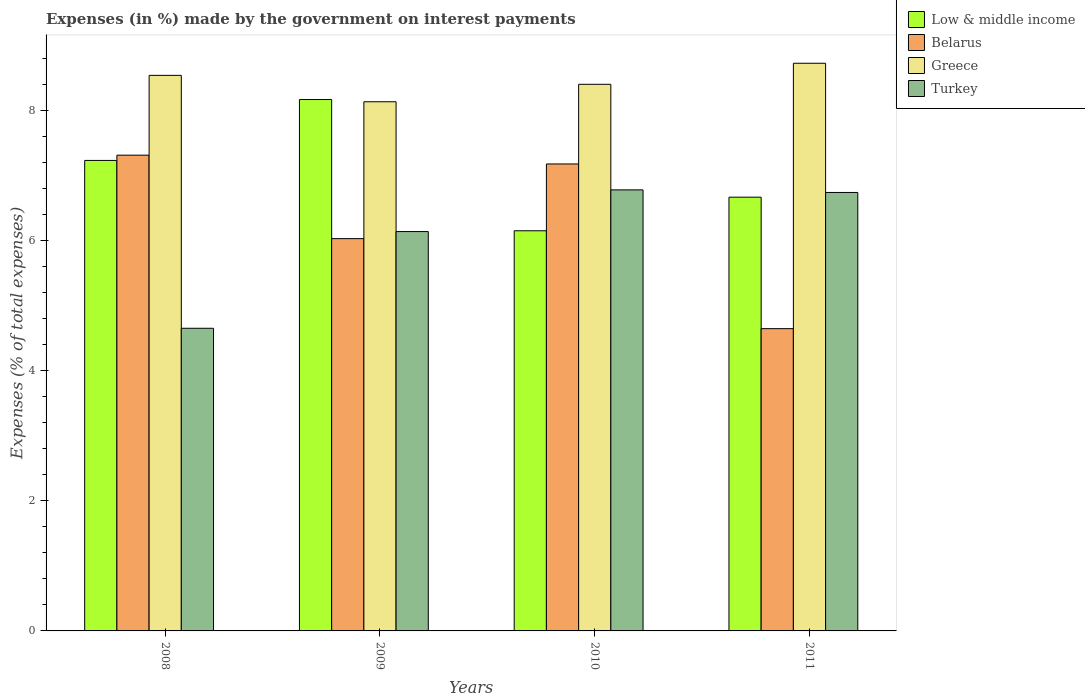How many different coloured bars are there?
Provide a short and direct response. 4. Are the number of bars on each tick of the X-axis equal?
Provide a short and direct response. Yes. What is the label of the 4th group of bars from the left?
Offer a terse response. 2011. What is the percentage of expenses made by the government on interest payments in Turkey in 2008?
Keep it short and to the point. 4.65. Across all years, what is the maximum percentage of expenses made by the government on interest payments in Greece?
Your response must be concise. 8.73. Across all years, what is the minimum percentage of expenses made by the government on interest payments in Low & middle income?
Give a very brief answer. 6.15. In which year was the percentage of expenses made by the government on interest payments in Greece maximum?
Make the answer very short. 2011. In which year was the percentage of expenses made by the government on interest payments in Greece minimum?
Make the answer very short. 2009. What is the total percentage of expenses made by the government on interest payments in Low & middle income in the graph?
Your response must be concise. 28.23. What is the difference between the percentage of expenses made by the government on interest payments in Belarus in 2008 and that in 2010?
Provide a short and direct response. 0.14. What is the difference between the percentage of expenses made by the government on interest payments in Low & middle income in 2010 and the percentage of expenses made by the government on interest payments in Turkey in 2009?
Keep it short and to the point. 0.01. What is the average percentage of expenses made by the government on interest payments in Greece per year?
Ensure brevity in your answer.  8.45. In the year 2009, what is the difference between the percentage of expenses made by the government on interest payments in Greece and percentage of expenses made by the government on interest payments in Low & middle income?
Your response must be concise. -0.03. In how many years, is the percentage of expenses made by the government on interest payments in Low & middle income greater than 4 %?
Keep it short and to the point. 4. What is the ratio of the percentage of expenses made by the government on interest payments in Turkey in 2008 to that in 2011?
Your response must be concise. 0.69. What is the difference between the highest and the second highest percentage of expenses made by the government on interest payments in Turkey?
Ensure brevity in your answer.  0.04. What is the difference between the highest and the lowest percentage of expenses made by the government on interest payments in Low & middle income?
Provide a short and direct response. 2.02. Is it the case that in every year, the sum of the percentage of expenses made by the government on interest payments in Greece and percentage of expenses made by the government on interest payments in Turkey is greater than the sum of percentage of expenses made by the government on interest payments in Low & middle income and percentage of expenses made by the government on interest payments in Belarus?
Give a very brief answer. No. Is it the case that in every year, the sum of the percentage of expenses made by the government on interest payments in Low & middle income and percentage of expenses made by the government on interest payments in Belarus is greater than the percentage of expenses made by the government on interest payments in Greece?
Your answer should be compact. Yes. How many bars are there?
Keep it short and to the point. 16. How many years are there in the graph?
Offer a terse response. 4. Are the values on the major ticks of Y-axis written in scientific E-notation?
Your answer should be compact. No. Does the graph contain grids?
Provide a succinct answer. No. What is the title of the graph?
Provide a short and direct response. Expenses (in %) made by the government on interest payments. What is the label or title of the X-axis?
Offer a very short reply. Years. What is the label or title of the Y-axis?
Make the answer very short. Expenses (% of total expenses). What is the Expenses (% of total expenses) of Low & middle income in 2008?
Your answer should be very brief. 7.24. What is the Expenses (% of total expenses) of Belarus in 2008?
Give a very brief answer. 7.32. What is the Expenses (% of total expenses) of Greece in 2008?
Ensure brevity in your answer.  8.54. What is the Expenses (% of total expenses) of Turkey in 2008?
Your response must be concise. 4.65. What is the Expenses (% of total expenses) in Low & middle income in 2009?
Your response must be concise. 8.17. What is the Expenses (% of total expenses) of Belarus in 2009?
Your answer should be compact. 6.03. What is the Expenses (% of total expenses) of Greece in 2009?
Provide a succinct answer. 8.14. What is the Expenses (% of total expenses) of Turkey in 2009?
Provide a succinct answer. 6.14. What is the Expenses (% of total expenses) in Low & middle income in 2010?
Provide a short and direct response. 6.15. What is the Expenses (% of total expenses) in Belarus in 2010?
Make the answer very short. 7.18. What is the Expenses (% of total expenses) of Greece in 2010?
Provide a succinct answer. 8.41. What is the Expenses (% of total expenses) in Turkey in 2010?
Make the answer very short. 6.78. What is the Expenses (% of total expenses) in Low & middle income in 2011?
Keep it short and to the point. 6.67. What is the Expenses (% of total expenses) in Belarus in 2011?
Keep it short and to the point. 4.65. What is the Expenses (% of total expenses) in Greece in 2011?
Make the answer very short. 8.73. What is the Expenses (% of total expenses) of Turkey in 2011?
Provide a succinct answer. 6.74. Across all years, what is the maximum Expenses (% of total expenses) of Low & middle income?
Give a very brief answer. 8.17. Across all years, what is the maximum Expenses (% of total expenses) of Belarus?
Ensure brevity in your answer.  7.32. Across all years, what is the maximum Expenses (% of total expenses) of Greece?
Ensure brevity in your answer.  8.73. Across all years, what is the maximum Expenses (% of total expenses) in Turkey?
Your response must be concise. 6.78. Across all years, what is the minimum Expenses (% of total expenses) of Low & middle income?
Give a very brief answer. 6.15. Across all years, what is the minimum Expenses (% of total expenses) of Belarus?
Keep it short and to the point. 4.65. Across all years, what is the minimum Expenses (% of total expenses) in Greece?
Provide a short and direct response. 8.14. Across all years, what is the minimum Expenses (% of total expenses) in Turkey?
Make the answer very short. 4.65. What is the total Expenses (% of total expenses) in Low & middle income in the graph?
Offer a terse response. 28.23. What is the total Expenses (% of total expenses) in Belarus in the graph?
Provide a short and direct response. 25.18. What is the total Expenses (% of total expenses) of Greece in the graph?
Offer a terse response. 33.82. What is the total Expenses (% of total expenses) in Turkey in the graph?
Provide a short and direct response. 24.32. What is the difference between the Expenses (% of total expenses) in Low & middle income in 2008 and that in 2009?
Provide a short and direct response. -0.94. What is the difference between the Expenses (% of total expenses) in Belarus in 2008 and that in 2009?
Ensure brevity in your answer.  1.28. What is the difference between the Expenses (% of total expenses) of Greece in 2008 and that in 2009?
Offer a terse response. 0.41. What is the difference between the Expenses (% of total expenses) of Turkey in 2008 and that in 2009?
Your answer should be very brief. -1.49. What is the difference between the Expenses (% of total expenses) of Low & middle income in 2008 and that in 2010?
Your answer should be compact. 1.08. What is the difference between the Expenses (% of total expenses) of Belarus in 2008 and that in 2010?
Offer a very short reply. 0.14. What is the difference between the Expenses (% of total expenses) of Greece in 2008 and that in 2010?
Provide a succinct answer. 0.14. What is the difference between the Expenses (% of total expenses) in Turkey in 2008 and that in 2010?
Offer a terse response. -2.13. What is the difference between the Expenses (% of total expenses) of Low & middle income in 2008 and that in 2011?
Offer a terse response. 0.56. What is the difference between the Expenses (% of total expenses) of Belarus in 2008 and that in 2011?
Your answer should be very brief. 2.67. What is the difference between the Expenses (% of total expenses) of Greece in 2008 and that in 2011?
Keep it short and to the point. -0.19. What is the difference between the Expenses (% of total expenses) in Turkey in 2008 and that in 2011?
Your response must be concise. -2.09. What is the difference between the Expenses (% of total expenses) in Low & middle income in 2009 and that in 2010?
Provide a short and direct response. 2.02. What is the difference between the Expenses (% of total expenses) in Belarus in 2009 and that in 2010?
Make the answer very short. -1.15. What is the difference between the Expenses (% of total expenses) in Greece in 2009 and that in 2010?
Offer a very short reply. -0.27. What is the difference between the Expenses (% of total expenses) in Turkey in 2009 and that in 2010?
Your answer should be compact. -0.64. What is the difference between the Expenses (% of total expenses) in Low & middle income in 2009 and that in 2011?
Make the answer very short. 1.5. What is the difference between the Expenses (% of total expenses) of Belarus in 2009 and that in 2011?
Make the answer very short. 1.38. What is the difference between the Expenses (% of total expenses) in Greece in 2009 and that in 2011?
Provide a succinct answer. -0.59. What is the difference between the Expenses (% of total expenses) of Turkey in 2009 and that in 2011?
Offer a terse response. -0.6. What is the difference between the Expenses (% of total expenses) of Low & middle income in 2010 and that in 2011?
Make the answer very short. -0.52. What is the difference between the Expenses (% of total expenses) of Belarus in 2010 and that in 2011?
Offer a terse response. 2.53. What is the difference between the Expenses (% of total expenses) in Greece in 2010 and that in 2011?
Make the answer very short. -0.32. What is the difference between the Expenses (% of total expenses) in Turkey in 2010 and that in 2011?
Offer a terse response. 0.04. What is the difference between the Expenses (% of total expenses) in Low & middle income in 2008 and the Expenses (% of total expenses) in Belarus in 2009?
Your answer should be very brief. 1.2. What is the difference between the Expenses (% of total expenses) in Low & middle income in 2008 and the Expenses (% of total expenses) in Greece in 2009?
Your response must be concise. -0.9. What is the difference between the Expenses (% of total expenses) in Low & middle income in 2008 and the Expenses (% of total expenses) in Turkey in 2009?
Offer a terse response. 1.09. What is the difference between the Expenses (% of total expenses) of Belarus in 2008 and the Expenses (% of total expenses) of Greece in 2009?
Your answer should be very brief. -0.82. What is the difference between the Expenses (% of total expenses) in Belarus in 2008 and the Expenses (% of total expenses) in Turkey in 2009?
Offer a very short reply. 1.18. What is the difference between the Expenses (% of total expenses) in Greece in 2008 and the Expenses (% of total expenses) in Turkey in 2009?
Give a very brief answer. 2.4. What is the difference between the Expenses (% of total expenses) in Low & middle income in 2008 and the Expenses (% of total expenses) in Belarus in 2010?
Provide a succinct answer. 0.05. What is the difference between the Expenses (% of total expenses) of Low & middle income in 2008 and the Expenses (% of total expenses) of Greece in 2010?
Keep it short and to the point. -1.17. What is the difference between the Expenses (% of total expenses) of Low & middle income in 2008 and the Expenses (% of total expenses) of Turkey in 2010?
Provide a succinct answer. 0.45. What is the difference between the Expenses (% of total expenses) of Belarus in 2008 and the Expenses (% of total expenses) of Greece in 2010?
Make the answer very short. -1.09. What is the difference between the Expenses (% of total expenses) of Belarus in 2008 and the Expenses (% of total expenses) of Turkey in 2010?
Your answer should be compact. 0.53. What is the difference between the Expenses (% of total expenses) in Greece in 2008 and the Expenses (% of total expenses) in Turkey in 2010?
Your answer should be compact. 1.76. What is the difference between the Expenses (% of total expenses) in Low & middle income in 2008 and the Expenses (% of total expenses) in Belarus in 2011?
Provide a short and direct response. 2.59. What is the difference between the Expenses (% of total expenses) of Low & middle income in 2008 and the Expenses (% of total expenses) of Greece in 2011?
Give a very brief answer. -1.49. What is the difference between the Expenses (% of total expenses) in Low & middle income in 2008 and the Expenses (% of total expenses) in Turkey in 2011?
Your answer should be very brief. 0.49. What is the difference between the Expenses (% of total expenses) in Belarus in 2008 and the Expenses (% of total expenses) in Greece in 2011?
Offer a terse response. -1.41. What is the difference between the Expenses (% of total expenses) in Belarus in 2008 and the Expenses (% of total expenses) in Turkey in 2011?
Ensure brevity in your answer.  0.57. What is the difference between the Expenses (% of total expenses) in Greece in 2008 and the Expenses (% of total expenses) in Turkey in 2011?
Provide a succinct answer. 1.8. What is the difference between the Expenses (% of total expenses) in Low & middle income in 2009 and the Expenses (% of total expenses) in Belarus in 2010?
Your answer should be very brief. 0.99. What is the difference between the Expenses (% of total expenses) of Low & middle income in 2009 and the Expenses (% of total expenses) of Greece in 2010?
Your answer should be very brief. -0.23. What is the difference between the Expenses (% of total expenses) in Low & middle income in 2009 and the Expenses (% of total expenses) in Turkey in 2010?
Give a very brief answer. 1.39. What is the difference between the Expenses (% of total expenses) in Belarus in 2009 and the Expenses (% of total expenses) in Greece in 2010?
Provide a short and direct response. -2.37. What is the difference between the Expenses (% of total expenses) of Belarus in 2009 and the Expenses (% of total expenses) of Turkey in 2010?
Ensure brevity in your answer.  -0.75. What is the difference between the Expenses (% of total expenses) in Greece in 2009 and the Expenses (% of total expenses) in Turkey in 2010?
Keep it short and to the point. 1.36. What is the difference between the Expenses (% of total expenses) of Low & middle income in 2009 and the Expenses (% of total expenses) of Belarus in 2011?
Keep it short and to the point. 3.52. What is the difference between the Expenses (% of total expenses) of Low & middle income in 2009 and the Expenses (% of total expenses) of Greece in 2011?
Provide a succinct answer. -0.56. What is the difference between the Expenses (% of total expenses) in Low & middle income in 2009 and the Expenses (% of total expenses) in Turkey in 2011?
Provide a short and direct response. 1.43. What is the difference between the Expenses (% of total expenses) in Belarus in 2009 and the Expenses (% of total expenses) in Greece in 2011?
Your answer should be compact. -2.7. What is the difference between the Expenses (% of total expenses) in Belarus in 2009 and the Expenses (% of total expenses) in Turkey in 2011?
Keep it short and to the point. -0.71. What is the difference between the Expenses (% of total expenses) of Greece in 2009 and the Expenses (% of total expenses) of Turkey in 2011?
Provide a short and direct response. 1.4. What is the difference between the Expenses (% of total expenses) of Low & middle income in 2010 and the Expenses (% of total expenses) of Belarus in 2011?
Provide a short and direct response. 1.51. What is the difference between the Expenses (% of total expenses) in Low & middle income in 2010 and the Expenses (% of total expenses) in Greece in 2011?
Your answer should be very brief. -2.58. What is the difference between the Expenses (% of total expenses) of Low & middle income in 2010 and the Expenses (% of total expenses) of Turkey in 2011?
Give a very brief answer. -0.59. What is the difference between the Expenses (% of total expenses) of Belarus in 2010 and the Expenses (% of total expenses) of Greece in 2011?
Provide a succinct answer. -1.55. What is the difference between the Expenses (% of total expenses) of Belarus in 2010 and the Expenses (% of total expenses) of Turkey in 2011?
Make the answer very short. 0.44. What is the difference between the Expenses (% of total expenses) of Greece in 2010 and the Expenses (% of total expenses) of Turkey in 2011?
Keep it short and to the point. 1.66. What is the average Expenses (% of total expenses) in Low & middle income per year?
Your response must be concise. 7.06. What is the average Expenses (% of total expenses) of Belarus per year?
Offer a very short reply. 6.29. What is the average Expenses (% of total expenses) in Greece per year?
Offer a very short reply. 8.45. What is the average Expenses (% of total expenses) in Turkey per year?
Your response must be concise. 6.08. In the year 2008, what is the difference between the Expenses (% of total expenses) in Low & middle income and Expenses (% of total expenses) in Belarus?
Ensure brevity in your answer.  -0.08. In the year 2008, what is the difference between the Expenses (% of total expenses) in Low & middle income and Expenses (% of total expenses) in Greece?
Your answer should be compact. -1.31. In the year 2008, what is the difference between the Expenses (% of total expenses) of Low & middle income and Expenses (% of total expenses) of Turkey?
Offer a terse response. 2.58. In the year 2008, what is the difference between the Expenses (% of total expenses) of Belarus and Expenses (% of total expenses) of Greece?
Offer a very short reply. -1.23. In the year 2008, what is the difference between the Expenses (% of total expenses) of Belarus and Expenses (% of total expenses) of Turkey?
Give a very brief answer. 2.66. In the year 2008, what is the difference between the Expenses (% of total expenses) in Greece and Expenses (% of total expenses) in Turkey?
Your response must be concise. 3.89. In the year 2009, what is the difference between the Expenses (% of total expenses) of Low & middle income and Expenses (% of total expenses) of Belarus?
Offer a very short reply. 2.14. In the year 2009, what is the difference between the Expenses (% of total expenses) of Low & middle income and Expenses (% of total expenses) of Greece?
Offer a very short reply. 0.03. In the year 2009, what is the difference between the Expenses (% of total expenses) of Low & middle income and Expenses (% of total expenses) of Turkey?
Provide a short and direct response. 2.03. In the year 2009, what is the difference between the Expenses (% of total expenses) in Belarus and Expenses (% of total expenses) in Greece?
Offer a terse response. -2.11. In the year 2009, what is the difference between the Expenses (% of total expenses) in Belarus and Expenses (% of total expenses) in Turkey?
Give a very brief answer. -0.11. In the year 2009, what is the difference between the Expenses (% of total expenses) of Greece and Expenses (% of total expenses) of Turkey?
Keep it short and to the point. 2. In the year 2010, what is the difference between the Expenses (% of total expenses) in Low & middle income and Expenses (% of total expenses) in Belarus?
Your answer should be very brief. -1.03. In the year 2010, what is the difference between the Expenses (% of total expenses) of Low & middle income and Expenses (% of total expenses) of Greece?
Make the answer very short. -2.25. In the year 2010, what is the difference between the Expenses (% of total expenses) of Low & middle income and Expenses (% of total expenses) of Turkey?
Give a very brief answer. -0.63. In the year 2010, what is the difference between the Expenses (% of total expenses) of Belarus and Expenses (% of total expenses) of Greece?
Make the answer very short. -1.23. In the year 2010, what is the difference between the Expenses (% of total expenses) of Belarus and Expenses (% of total expenses) of Turkey?
Give a very brief answer. 0.4. In the year 2010, what is the difference between the Expenses (% of total expenses) of Greece and Expenses (% of total expenses) of Turkey?
Make the answer very short. 1.62. In the year 2011, what is the difference between the Expenses (% of total expenses) in Low & middle income and Expenses (% of total expenses) in Belarus?
Your answer should be compact. 2.02. In the year 2011, what is the difference between the Expenses (% of total expenses) of Low & middle income and Expenses (% of total expenses) of Greece?
Your response must be concise. -2.06. In the year 2011, what is the difference between the Expenses (% of total expenses) in Low & middle income and Expenses (% of total expenses) in Turkey?
Offer a terse response. -0.07. In the year 2011, what is the difference between the Expenses (% of total expenses) in Belarus and Expenses (% of total expenses) in Greece?
Give a very brief answer. -4.08. In the year 2011, what is the difference between the Expenses (% of total expenses) of Belarus and Expenses (% of total expenses) of Turkey?
Give a very brief answer. -2.09. In the year 2011, what is the difference between the Expenses (% of total expenses) in Greece and Expenses (% of total expenses) in Turkey?
Your response must be concise. 1.99. What is the ratio of the Expenses (% of total expenses) in Low & middle income in 2008 to that in 2009?
Your answer should be compact. 0.89. What is the ratio of the Expenses (% of total expenses) in Belarus in 2008 to that in 2009?
Offer a very short reply. 1.21. What is the ratio of the Expenses (% of total expenses) in Greece in 2008 to that in 2009?
Your response must be concise. 1.05. What is the ratio of the Expenses (% of total expenses) in Turkey in 2008 to that in 2009?
Your answer should be very brief. 0.76. What is the ratio of the Expenses (% of total expenses) in Low & middle income in 2008 to that in 2010?
Make the answer very short. 1.18. What is the ratio of the Expenses (% of total expenses) of Belarus in 2008 to that in 2010?
Offer a terse response. 1.02. What is the ratio of the Expenses (% of total expenses) in Greece in 2008 to that in 2010?
Provide a short and direct response. 1.02. What is the ratio of the Expenses (% of total expenses) in Turkey in 2008 to that in 2010?
Ensure brevity in your answer.  0.69. What is the ratio of the Expenses (% of total expenses) in Low & middle income in 2008 to that in 2011?
Give a very brief answer. 1.08. What is the ratio of the Expenses (% of total expenses) in Belarus in 2008 to that in 2011?
Make the answer very short. 1.57. What is the ratio of the Expenses (% of total expenses) in Greece in 2008 to that in 2011?
Offer a terse response. 0.98. What is the ratio of the Expenses (% of total expenses) of Turkey in 2008 to that in 2011?
Make the answer very short. 0.69. What is the ratio of the Expenses (% of total expenses) of Low & middle income in 2009 to that in 2010?
Keep it short and to the point. 1.33. What is the ratio of the Expenses (% of total expenses) in Belarus in 2009 to that in 2010?
Give a very brief answer. 0.84. What is the ratio of the Expenses (% of total expenses) of Greece in 2009 to that in 2010?
Your response must be concise. 0.97. What is the ratio of the Expenses (% of total expenses) in Turkey in 2009 to that in 2010?
Ensure brevity in your answer.  0.91. What is the ratio of the Expenses (% of total expenses) in Low & middle income in 2009 to that in 2011?
Provide a succinct answer. 1.23. What is the ratio of the Expenses (% of total expenses) of Belarus in 2009 to that in 2011?
Offer a very short reply. 1.3. What is the ratio of the Expenses (% of total expenses) in Greece in 2009 to that in 2011?
Offer a terse response. 0.93. What is the ratio of the Expenses (% of total expenses) of Turkey in 2009 to that in 2011?
Make the answer very short. 0.91. What is the ratio of the Expenses (% of total expenses) in Low & middle income in 2010 to that in 2011?
Give a very brief answer. 0.92. What is the ratio of the Expenses (% of total expenses) in Belarus in 2010 to that in 2011?
Keep it short and to the point. 1.54. What is the ratio of the Expenses (% of total expenses) of Greece in 2010 to that in 2011?
Provide a short and direct response. 0.96. What is the ratio of the Expenses (% of total expenses) of Turkey in 2010 to that in 2011?
Provide a succinct answer. 1.01. What is the difference between the highest and the second highest Expenses (% of total expenses) of Low & middle income?
Offer a terse response. 0.94. What is the difference between the highest and the second highest Expenses (% of total expenses) in Belarus?
Your answer should be compact. 0.14. What is the difference between the highest and the second highest Expenses (% of total expenses) in Greece?
Your answer should be very brief. 0.19. What is the difference between the highest and the second highest Expenses (% of total expenses) in Turkey?
Your answer should be compact. 0.04. What is the difference between the highest and the lowest Expenses (% of total expenses) in Low & middle income?
Provide a succinct answer. 2.02. What is the difference between the highest and the lowest Expenses (% of total expenses) in Belarus?
Your answer should be compact. 2.67. What is the difference between the highest and the lowest Expenses (% of total expenses) of Greece?
Your response must be concise. 0.59. What is the difference between the highest and the lowest Expenses (% of total expenses) in Turkey?
Give a very brief answer. 2.13. 